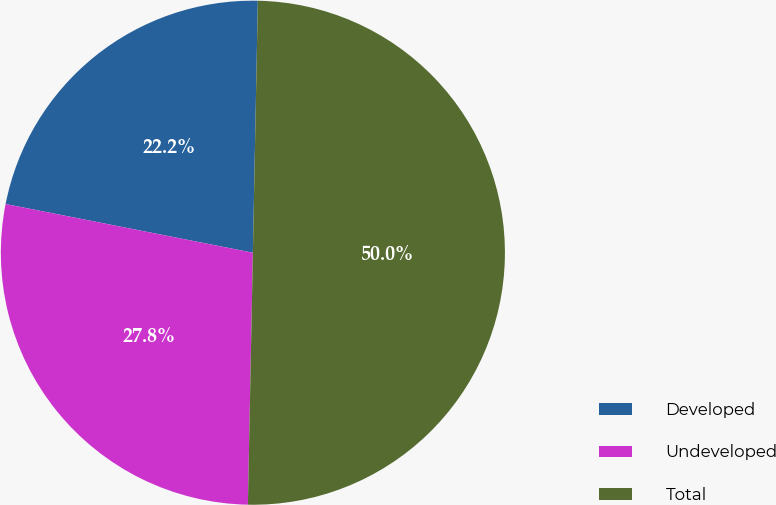<chart> <loc_0><loc_0><loc_500><loc_500><pie_chart><fcel>Developed<fcel>Undeveloped<fcel>Total<nl><fcel>22.22%<fcel>27.78%<fcel>50.0%<nl></chart> 